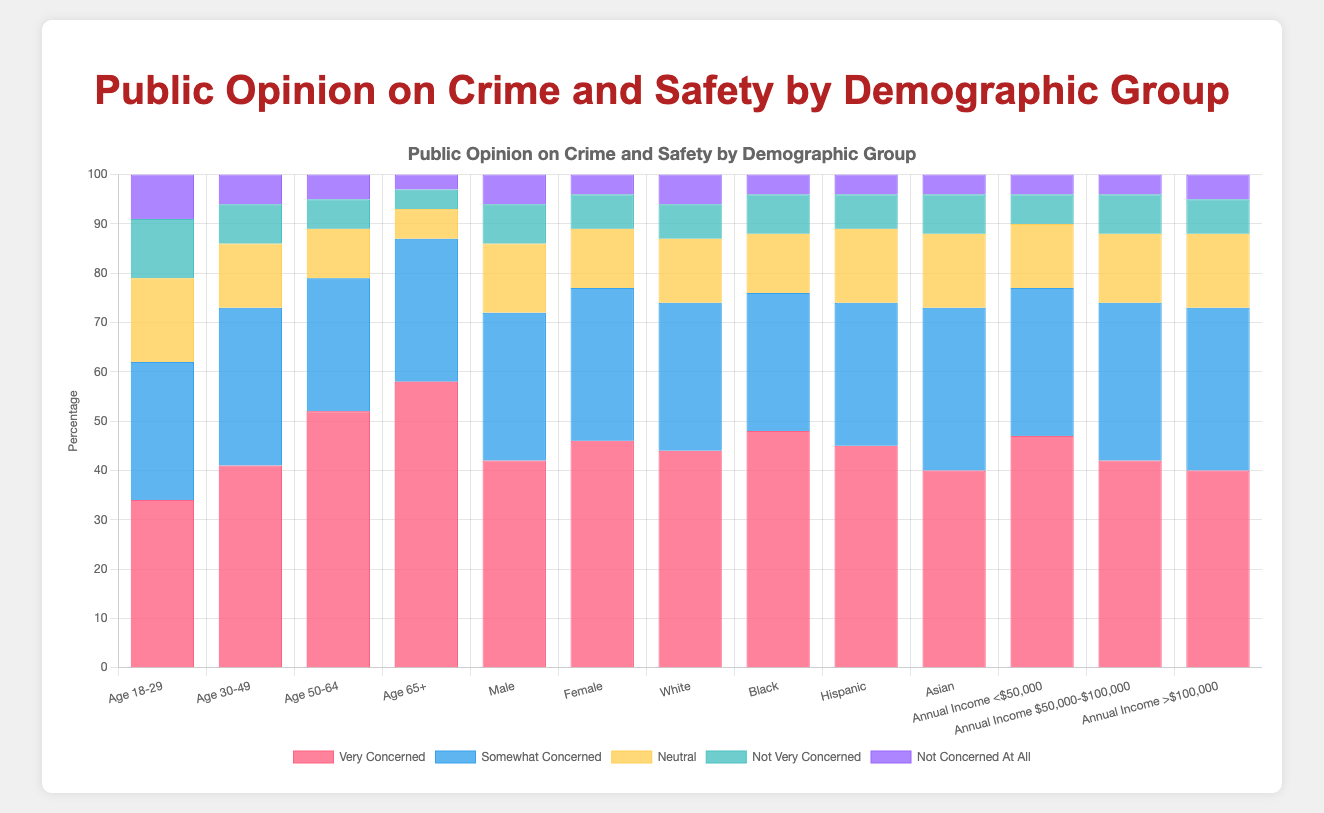What's the percentage of people aged 18-29 who are neutral? To determine this, we simply look at the height of the "Neutral" bar for the "Age 18-29" group in the chart. The chart shows that 17% of people aged 18-29 are neutral about crime and safety.
Answer: 17% Which demographic group has the highest percentage of people who are very concerned? To answer this, identify the tallest "Very Concerned" bar across all demographic groups in the chart. The tallest "Very Concerned" bar belongs to the "Age 65+" group, which has 58% very concerned.
Answer: Age 65+ Comparing males and females, which group has a higher percentage of people who are somewhat concerned? Compare the heights of the "Somewhat Concerned" bars for the Male and Female groups. The chart shows that 31% of females are somewhat concerned compared to 30% of males.
Answer: Female What's the difference in the percentage of very concerned people between the groups aged 50-64 and 18-29? First, find the percentages for "Very Concerned" in both age groups. "Age 50-64" is 52% and "Age 18-29" is 34%. Subtract the two values: 52% - 34% = 18%.
Answer: 18% How do the percentages of people who are not concerned at all compare between Asians and those with annual income >$100,000? Examine the "Not Concerned At All" bars for both "Asian" and "Annual Income >$100,000" groups. Both groups show 4% and 5% respectively. Comparing, Asians have 1% lower than those with annual income >$100,000.
Answer: Asians have 1% lower Which demographic group has the lowest percentage of people who are neutral? Identify the shortest "Neutral" bar across all demographic groups. The "Age 65+" group has the lowest percentage at 6%.
Answer: Age 65+ What's the average percentage of very concerned people across all age groups (18-29, 30-49, 50-64, 65+)? Add the percentages of very concerned people from all age groups: 34% + 41% + 52% + 58% = 185%. Divide this sum by the number of age groups, 4: 185% / 4 = 46.25%.
Answer: 46.25% What is the sum of the percentages of people who are not very concerned and not concerned at all in the Hispanic group? Look at the Hispanic group's data: "Not Very Concerned" is 7% and "Not Concerned At All" is 4%. Add them together: 7% + 4% = 11%.
Answer: 11% What is the combined percentage of people who are either somewhat concerned or very concerned in the Male group? From the chart, the Male group has 42% very concerned and 30% somewhat concerned. Adding these gives: 42% + 30% = 72%.
Answer: 72% In the group with an annual income of $50,000-$100,000, what is the total percentage of people who are neutral or not very concerned? In this income group, "Neutral" is 14% and "Not Very Concerned" is 8%. Adding these values: 14% + 8% = 22%.
Answer: 22% 